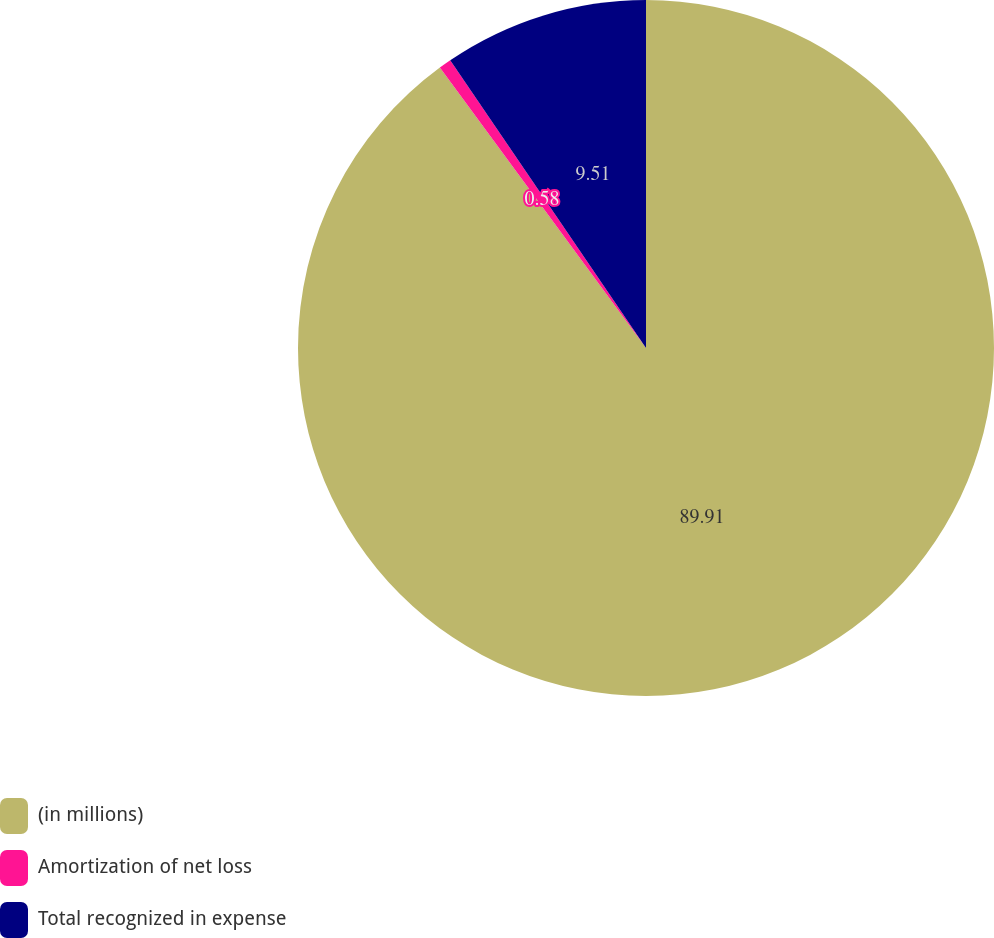<chart> <loc_0><loc_0><loc_500><loc_500><pie_chart><fcel>(in millions)<fcel>Amortization of net loss<fcel>Total recognized in expense<nl><fcel>89.91%<fcel>0.58%<fcel>9.51%<nl></chart> 